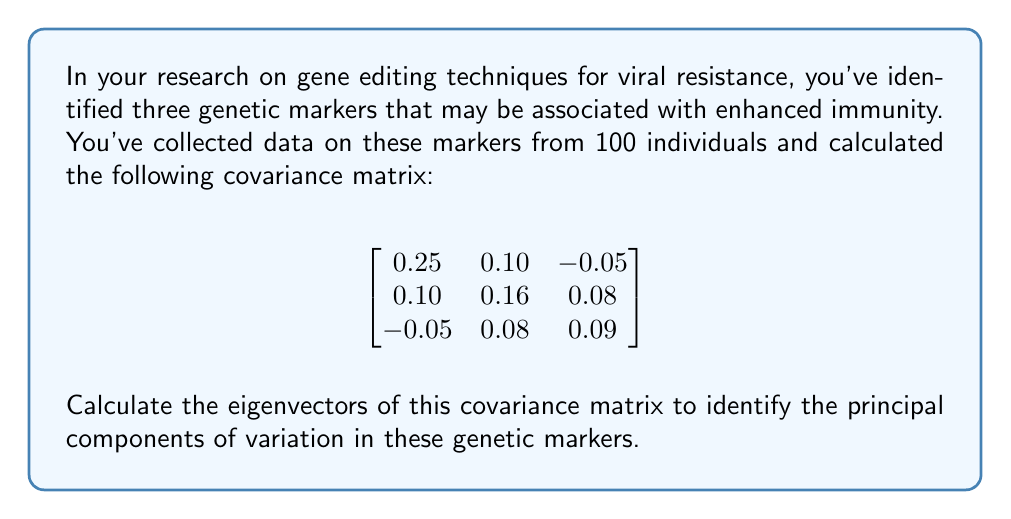Can you solve this math problem? To find the eigenvectors of the covariance matrix, we need to follow these steps:

1) First, we need to find the eigenvalues by solving the characteristic equation:
   $\det(A - \lambda I) = 0$, where $A$ is our covariance matrix and $I$ is the 3x3 identity matrix.

2) The characteristic equation is:
   $$\begin{vmatrix}
   0.25 - \lambda & 0.10 & -0.05 \\
   0.10 & 0.16 - \lambda & 0.08 \\
   -0.05 & 0.08 & 0.09 - \lambda
   \end{vmatrix} = 0$$

3) Expanding this determinant gives us:
   $-\lambda^3 + 0.5\lambda^2 - 0.0731\lambda + 0.00324 = 0$

4) Solving this cubic equation (which can be done numerically), we get the eigenvalues:
   $\lambda_1 \approx 0.3373$, $\lambda_2 \approx 0.1280$, $\lambda_3 \approx 0.0347$

5) For each eigenvalue, we solve $(A - \lambda_i I)\mathbf{v} = \mathbf{0}$ to find the corresponding eigenvector.

6) For $\lambda_1 \approx 0.3373$:
   $$\begin{bmatrix}
   -0.0873 & 0.10 & -0.05 \\
   0.10 & -0.1773 & 0.08 \\
   -0.05 & 0.08 & -0.2473
   \end{bmatrix}\mathbf{v_1} = \mathbf{0}$$

   Solving this gives us: $\mathbf{v_1} \approx (0.7071, 0.6533, -0.2706)$

7) Similarly for $\lambda_2 \approx 0.1280$ and $\lambda_3 \approx 0.0347$, we get:
   $\mathbf{v_2} \approx (-0.0404, 0.5425, 0.8391)$
   $\mathbf{v_3} \approx (0.7060, -0.5280, 0.4718)$

8) These eigenvectors should be normalized to unit length.
Answer: The normalized eigenvectors of the covariance matrix are:

$\mathbf{v_1} \approx (0.7071, 0.6533, -0.2706)$
$\mathbf{v_2} \approx (-0.0404, 0.5425, 0.8391)$
$\mathbf{v_3} \approx (0.7060, -0.5280, 0.4718)$

These eigenvectors represent the principal components of variation in the genetic markers, with $\mathbf{v_1}$ corresponding to the direction of greatest variation. 